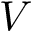<formula> <loc_0><loc_0><loc_500><loc_500>V</formula> 